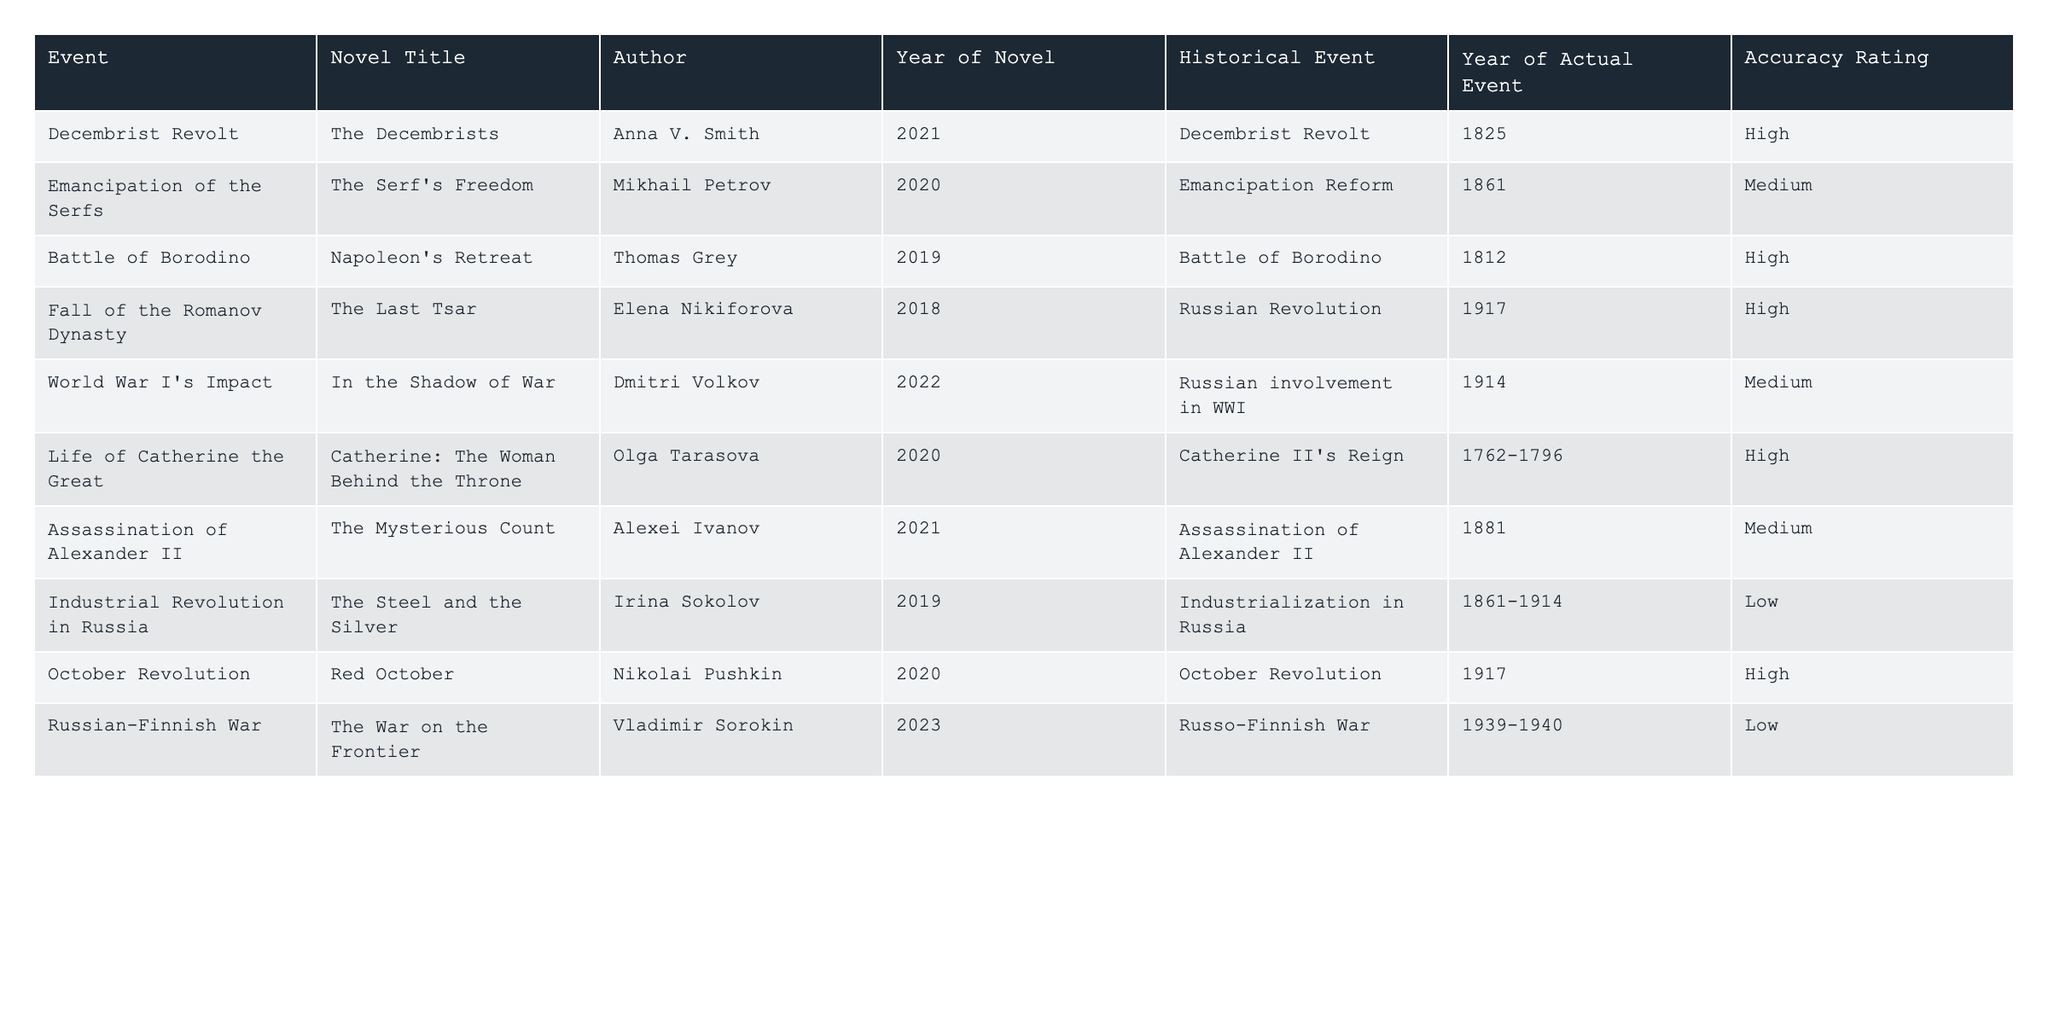What novel depicts the Battle of Borodino? The table indicates that "Napoleon's Retreat" by Thomas Grey depicts the Battle of Borodino.
Answer: "Napoleon's Retreat" How many events have a high accuracy rating? By counting the rows with "High" under the Accuracy Rating column, we find there are 6 events with high accuracy.
Answer: 6 What is the historical event associated with the novel "The Last Tsar"? Referring to the table, "The Last Tsar" is associated with the historical event of the Russian Revolution.
Answer: Russian Revolution Which author wrote a novel about the assassination of Alexander II? The table shows that "The Mysterious Count," written by Alexei Ivanov, is about the assassination of Alexander II.
Answer: Alexei Ivanov Is the Emancipation of the Serfs depicted accurately in the novel "The Serf's Freedom"? According to the table, "The Serf's Freedom" has a medium accuracy rating, indicating it is not fully accurate.
Answer: No What is the difference between the number of low accuracy ratings and the number of high accuracy ratings? There are 3 low accuracy ratings and 6 high accuracy ratings. The difference is 6 - 3 = 3.
Answer: 3 Can you name two novels that depict events from the year 1917? The table lists "The Last Tsar" and "Red October" as novels depicting events from 1917.
Answer: "The Last Tsar" and "Red October" Which historical event has the lowest accuracy rating in the novels listed? "Industrial Revolution in Russia" has the lowest accuracy rating, categorized as low in the table.
Answer: Industrial Revolution in Russia Was the Russian-Finnish War accurately represented in any novel? The table shows that the novel "The War on the Frontier" regarding this war has a low accuracy rating, indicating inaccuracies.
Answer: No Which event has a medium accuracy rating and is connected to World War I? "In the Shadow of War," concerning Russian involvement in WWI, has a medium accuracy rating.
Answer: In the Shadow of War 